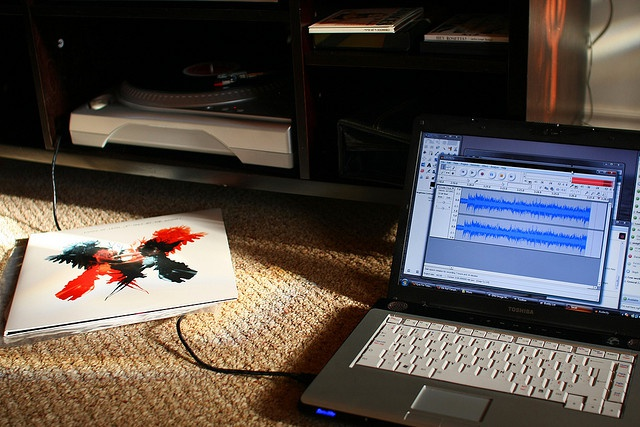Describe the objects in this image and their specific colors. I can see laptop in black, darkgray, and lavender tones, book in black, ivory, red, and tan tones, and keyboard in black, darkgray, beige, and gray tones in this image. 